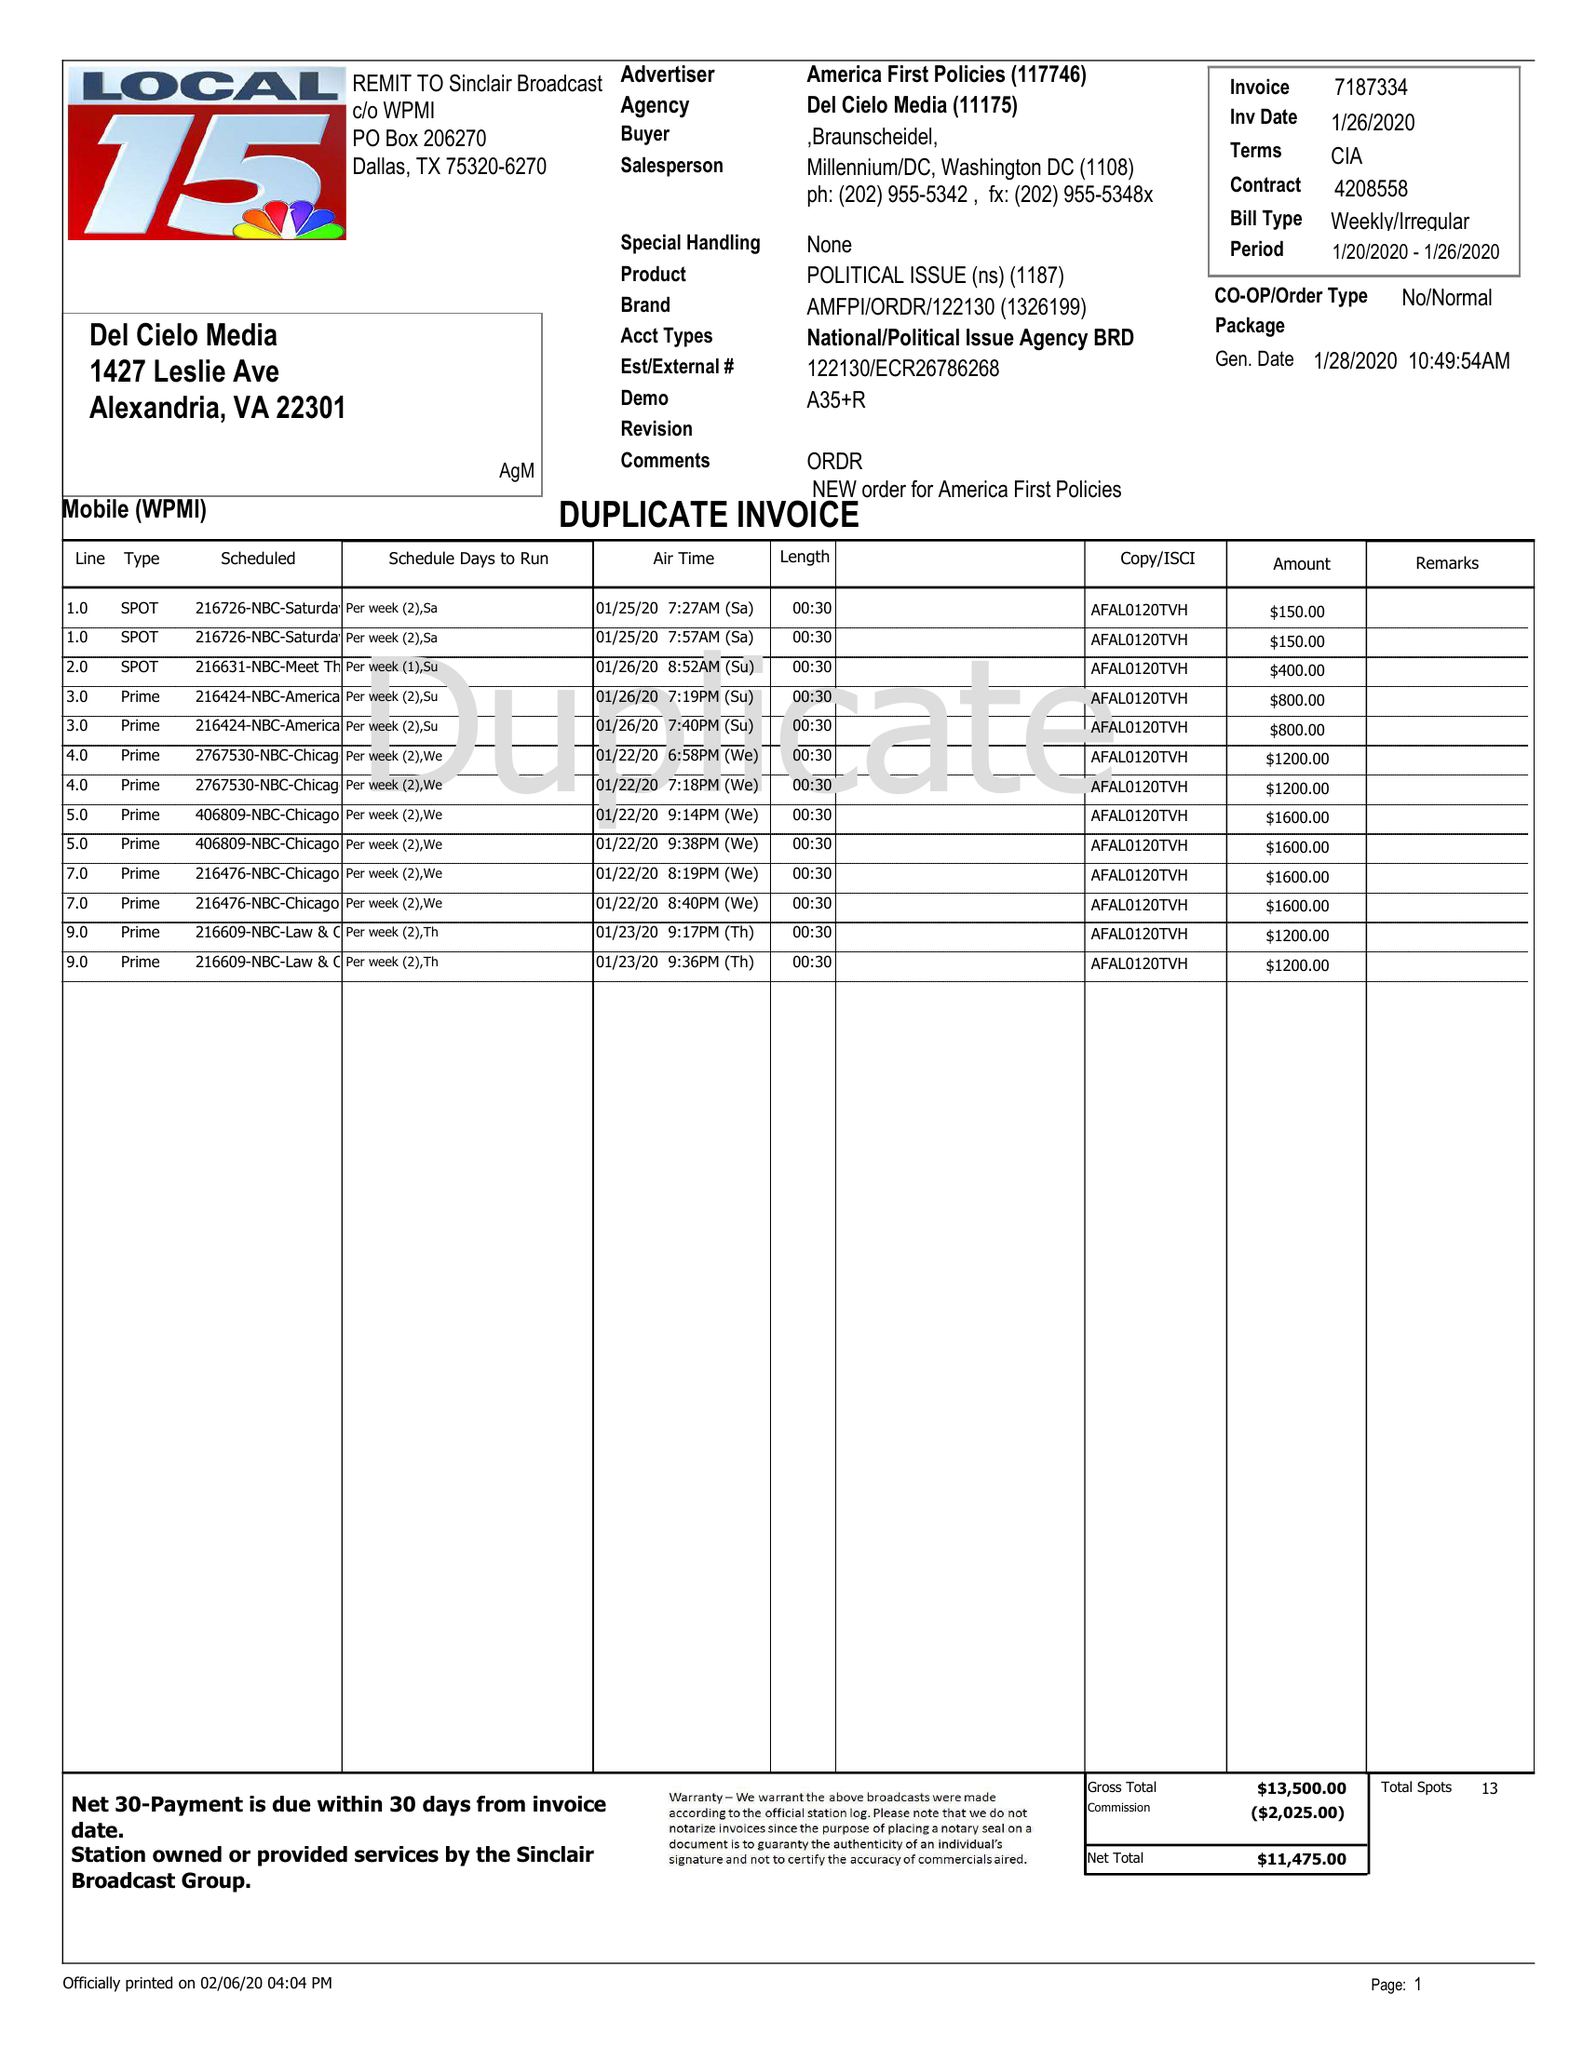What is the value for the contract_num?
Answer the question using a single word or phrase. 7187334 